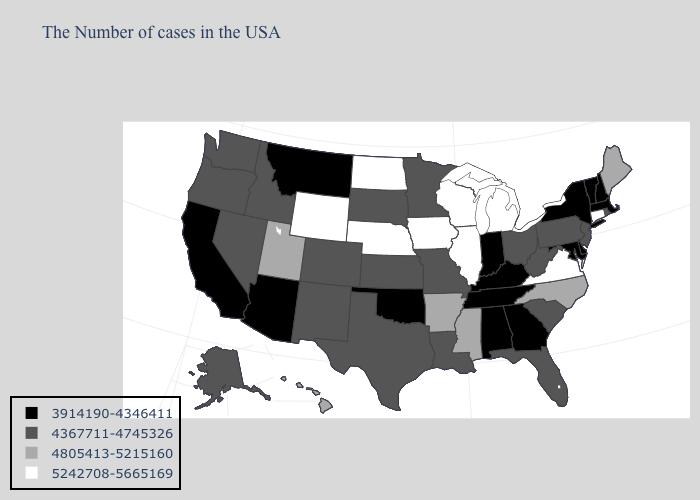What is the value of Florida?
Give a very brief answer. 4367711-4745326. Which states have the lowest value in the Northeast?
Be succinct. Massachusetts, New Hampshire, Vermont, New York. What is the highest value in states that border Vermont?
Quick response, please. 3914190-4346411. Does New Mexico have a lower value than Colorado?
Concise answer only. No. Does the map have missing data?
Give a very brief answer. No. Among the states that border Montana , which have the highest value?
Keep it brief. North Dakota, Wyoming. Name the states that have a value in the range 4367711-4745326?
Be succinct. Rhode Island, New Jersey, Pennsylvania, South Carolina, West Virginia, Ohio, Florida, Louisiana, Missouri, Minnesota, Kansas, Texas, South Dakota, Colorado, New Mexico, Idaho, Nevada, Washington, Oregon, Alaska. What is the value of Rhode Island?
Give a very brief answer. 4367711-4745326. Name the states that have a value in the range 4367711-4745326?
Short answer required. Rhode Island, New Jersey, Pennsylvania, South Carolina, West Virginia, Ohio, Florida, Louisiana, Missouri, Minnesota, Kansas, Texas, South Dakota, Colorado, New Mexico, Idaho, Nevada, Washington, Oregon, Alaska. Does Vermont have the highest value in the USA?
Keep it brief. No. What is the value of Michigan?
Give a very brief answer. 5242708-5665169. Name the states that have a value in the range 5242708-5665169?
Concise answer only. Connecticut, Virginia, Michigan, Wisconsin, Illinois, Iowa, Nebraska, North Dakota, Wyoming. Among the states that border Kansas , which have the lowest value?
Keep it brief. Oklahoma. What is the value of Rhode Island?
Write a very short answer. 4367711-4745326. 